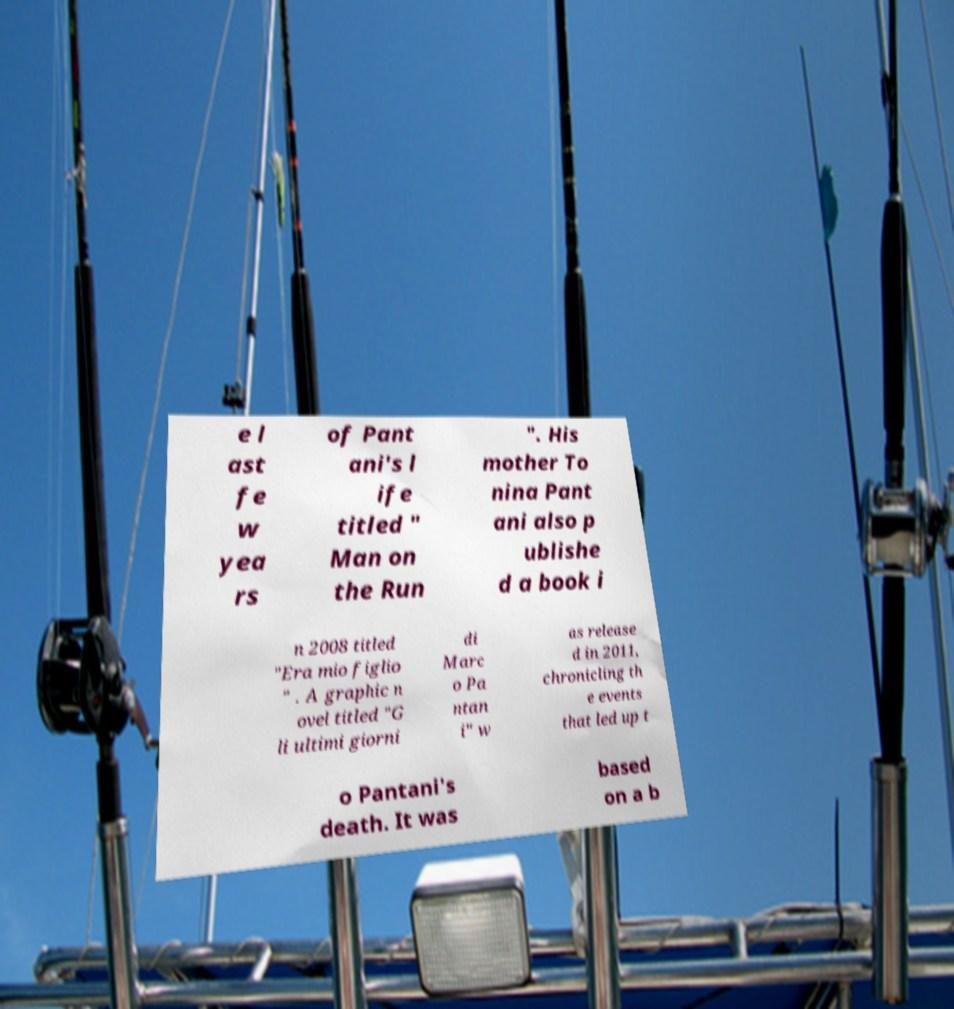Can you read and provide the text displayed in the image?This photo seems to have some interesting text. Can you extract and type it out for me? e l ast fe w yea rs of Pant ani's l ife titled " Man on the Run ". His mother To nina Pant ani also p ublishe d a book i n 2008 titled "Era mio figlio " . A graphic n ovel titled "G li ultimi giorni di Marc o Pa ntan i" w as release d in 2011, chronicling th e events that led up t o Pantani's death. It was based on a b 